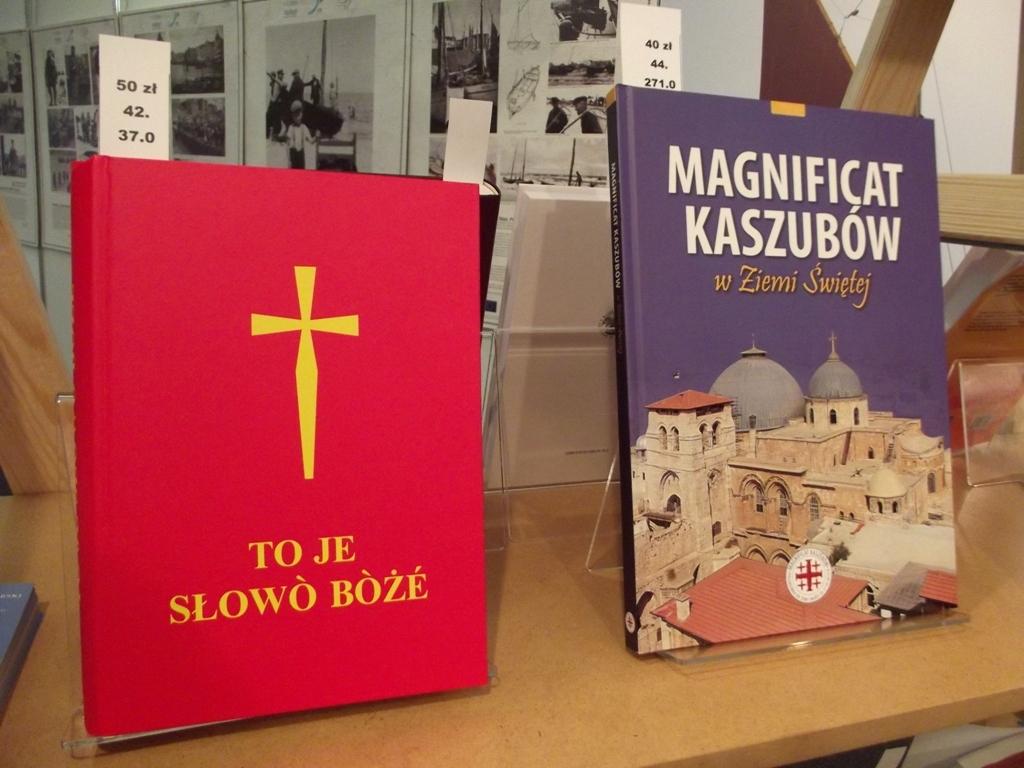What is the title of the red book?
Make the answer very short. To je slowo boze. 